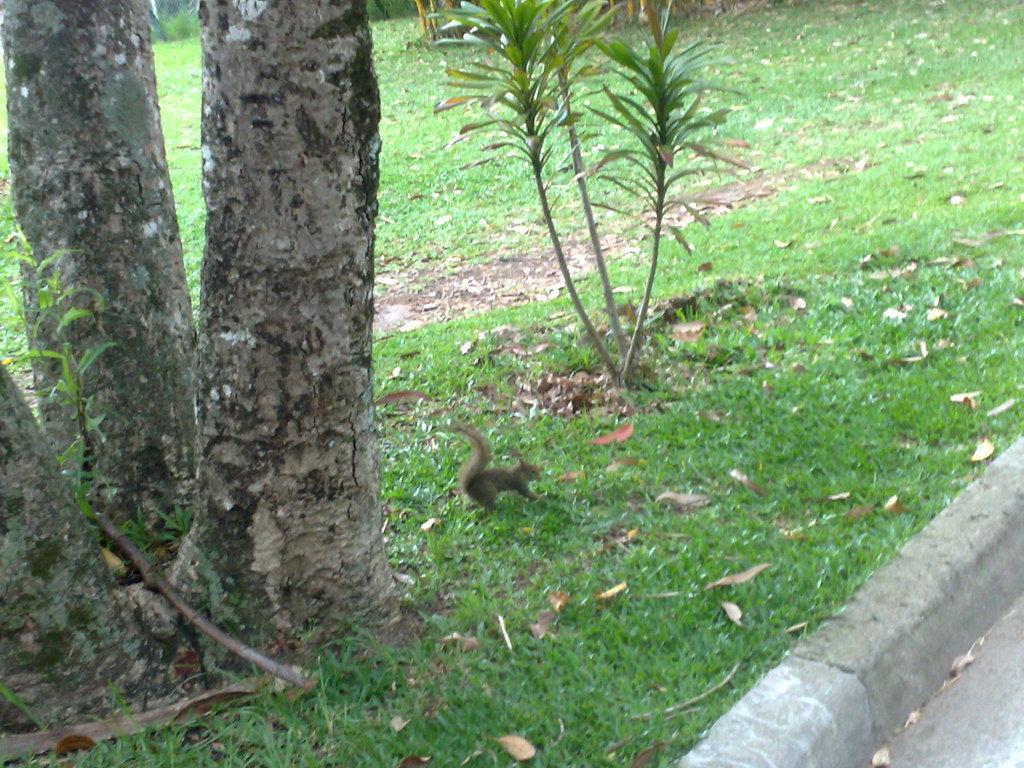How would you summarize this image in a sentence or two? In this image we can see a squirrel on the grassy land. There is a bark of a tree on the left side of the image. There is a plant in the middle of the image. We can see dry leaves on the grassy land. It seems like pavement in the right bottom of the image. 